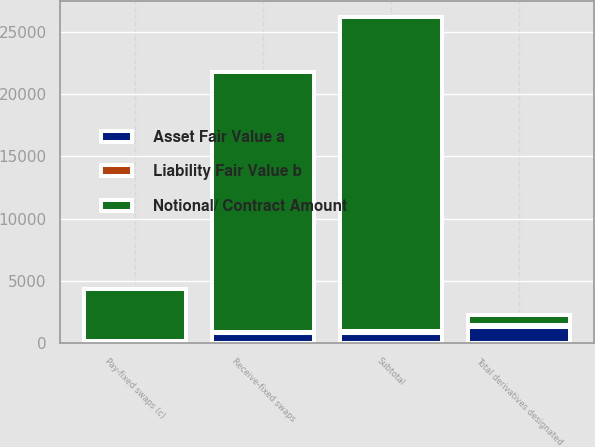Convert chart. <chart><loc_0><loc_0><loc_500><loc_500><stacked_bar_chart><ecel><fcel>Receive-fixed swaps<fcel>Pay-fixed swaps (c)<fcel>Subtotal<fcel>Total derivatives designated<nl><fcel>Notional/ Contract Amount<fcel>20930<fcel>4233<fcel>25163<fcel>827<nl><fcel>Asset Fair Value a<fcel>827<fcel>3<fcel>830<fcel>1261<nl><fcel>Liability Fair Value b<fcel>38<fcel>138<fcel>176<fcel>186<nl></chart> 